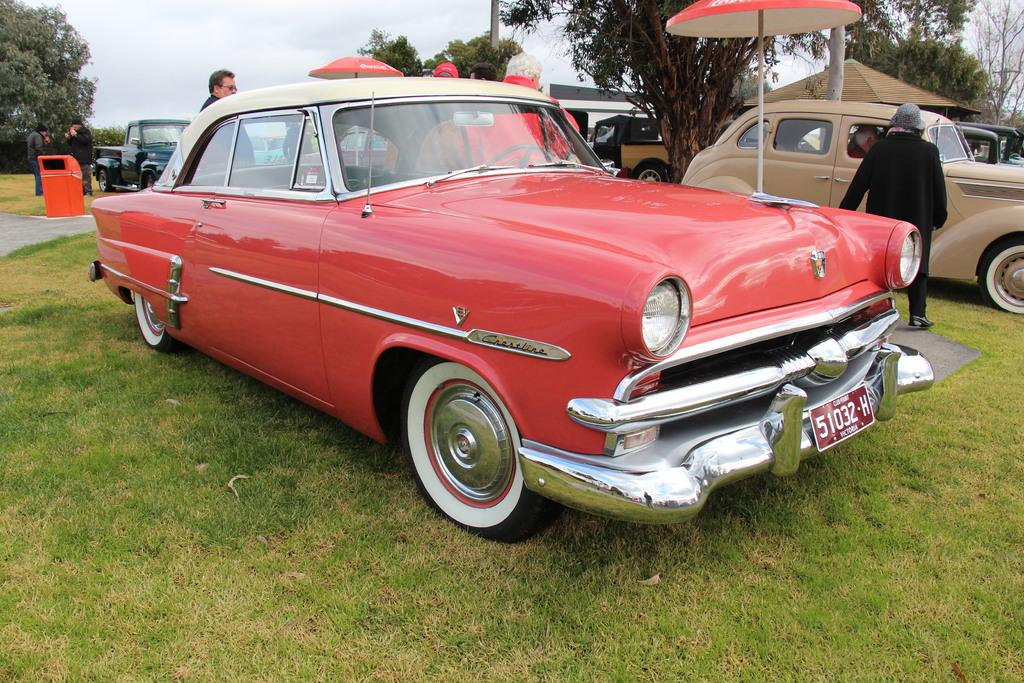What types of objects are present in the image? There are vehicles, people, poles, an umbrella, trees, a path, a trash bin, and the sky visible in the image. What is the ground like in the image? The ground with grass is visible in the image. Can you describe the setting of the image? The image features a grassy area with trees, a path, and a trash bin, as well as vehicles and people. What might be used for shelter from the sun or rain in the image? The umbrella in the image could be used for shelter from the sun or rain. How many apples are being traded by the fireman in the image? There is no fireman or apples present in the image. What type of trade is happening between the vehicles in the image? There is no trade happening between the vehicles in the image; they are simply parked or moving. 